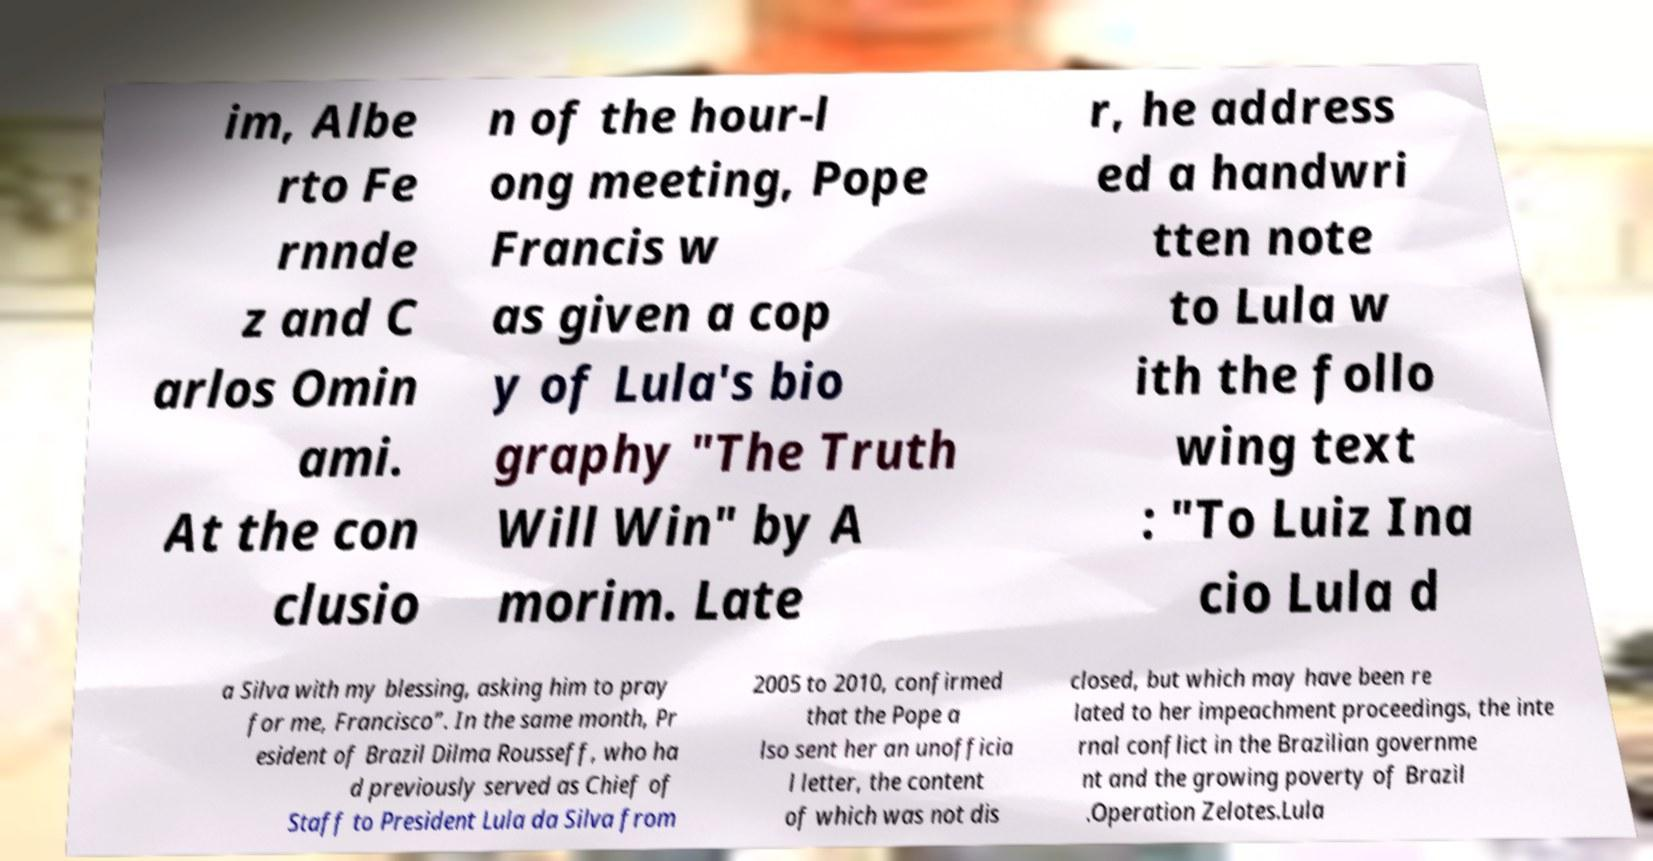There's text embedded in this image that I need extracted. Can you transcribe it verbatim? im, Albe rto Fe rnnde z and C arlos Omin ami. At the con clusio n of the hour-l ong meeting, Pope Francis w as given a cop y of Lula's bio graphy "The Truth Will Win" by A morim. Late r, he address ed a handwri tten note to Lula w ith the follo wing text : "To Luiz Ina cio Lula d a Silva with my blessing, asking him to pray for me, Francisco”. In the same month, Pr esident of Brazil Dilma Rousseff, who ha d previously served as Chief of Staff to President Lula da Silva from 2005 to 2010, confirmed that the Pope a lso sent her an unofficia l letter, the content of which was not dis closed, but which may have been re lated to her impeachment proceedings, the inte rnal conflict in the Brazilian governme nt and the growing poverty of Brazil .Operation Zelotes.Lula 